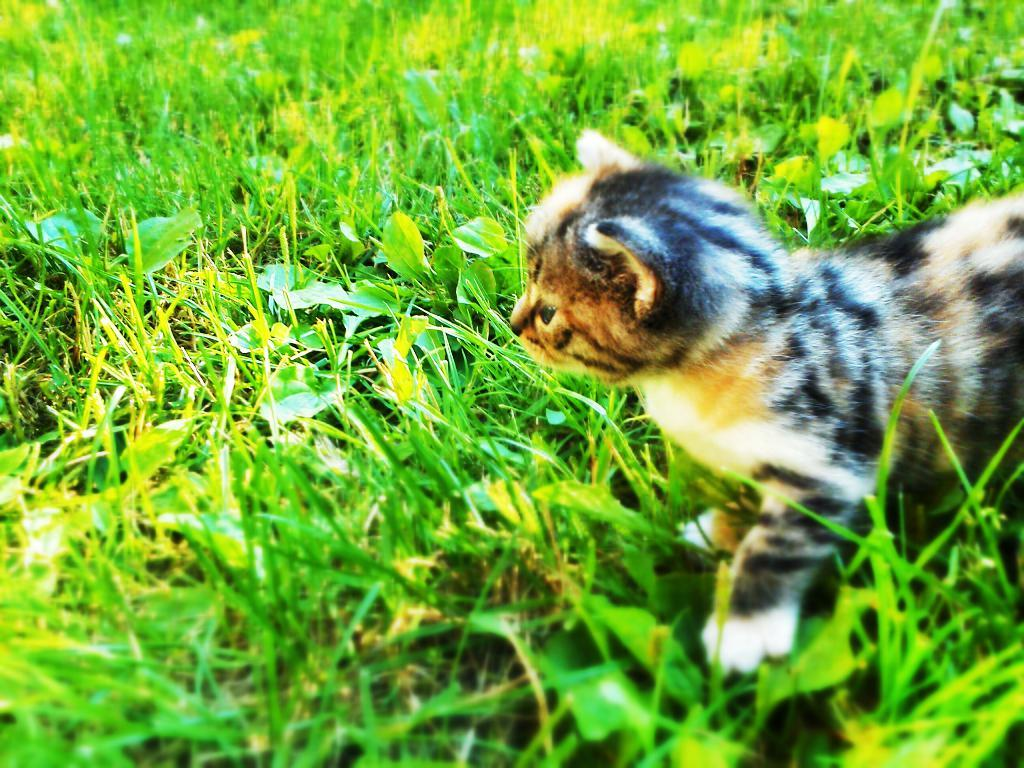What type of animal is in the image? There is a cat in the image. Where is the cat located? The cat is on the grass. What type of drug is the cat holding in the image? There is no drug present in the image, and the cat is not holding anything. 